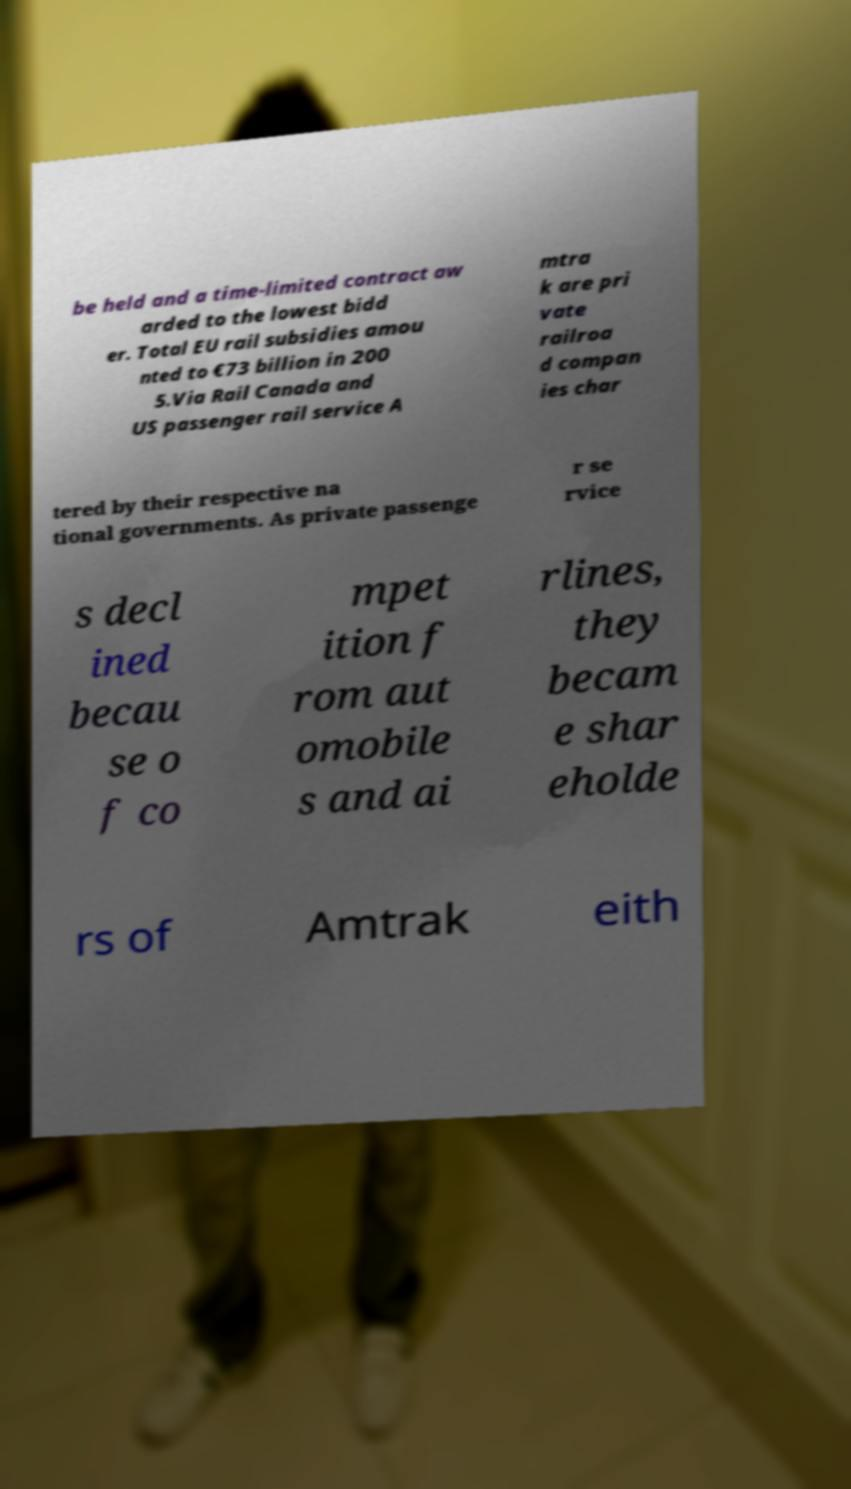Can you accurately transcribe the text from the provided image for me? be held and a time-limited contract aw arded to the lowest bidd er. Total EU rail subsidies amou nted to €73 billion in 200 5.Via Rail Canada and US passenger rail service A mtra k are pri vate railroa d compan ies char tered by their respective na tional governments. As private passenge r se rvice s decl ined becau se o f co mpet ition f rom aut omobile s and ai rlines, they becam e shar eholde rs of Amtrak eith 